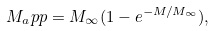Convert formula to latex. <formula><loc_0><loc_0><loc_500><loc_500>M _ { a } p p = M _ { \infty } ( 1 - e ^ { - M / M _ { \infty } } ) ,</formula> 